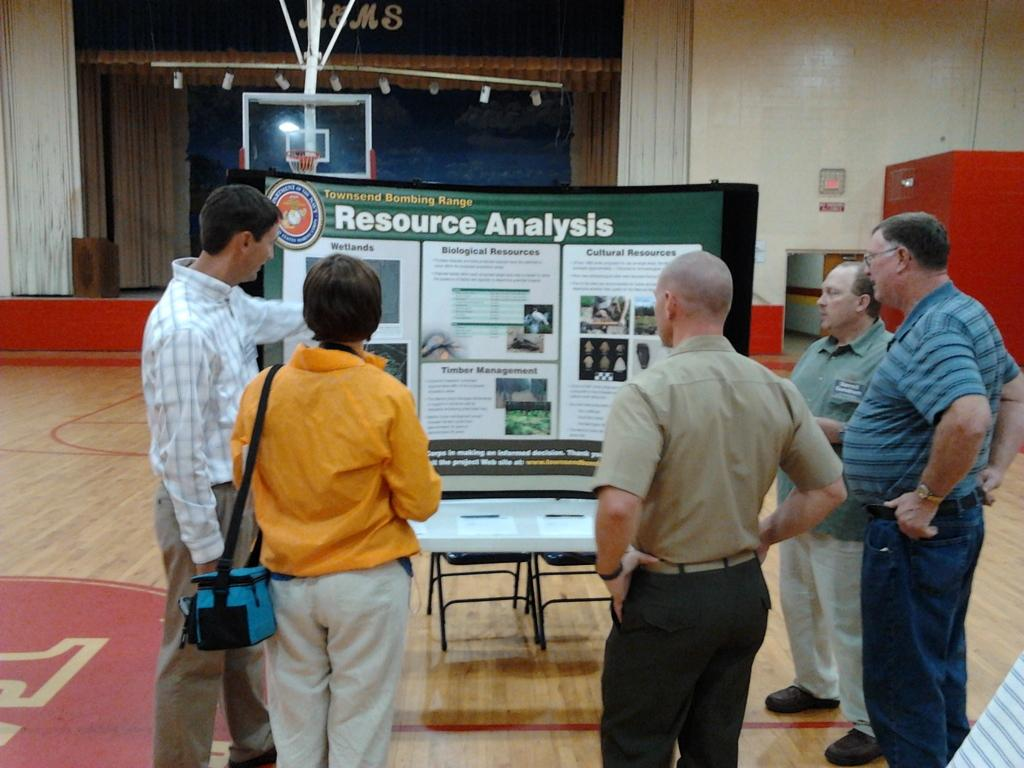How many people are present in the image? There are five persons standing in the image. What objects are present in the image that might be used for sitting? There are chairs in the image. What can be seen on the board in the image? The facts do not specify what is on the board, so we cannot answer that question. What is visible in the background of the image? There is a wall in the background of the image. What type of church can be seen in the background of the image? There is no church present in the image; only a wall is visible in the background. Are there any slaves depicted in the image? There is no mention of slaves or any related context in the image. 